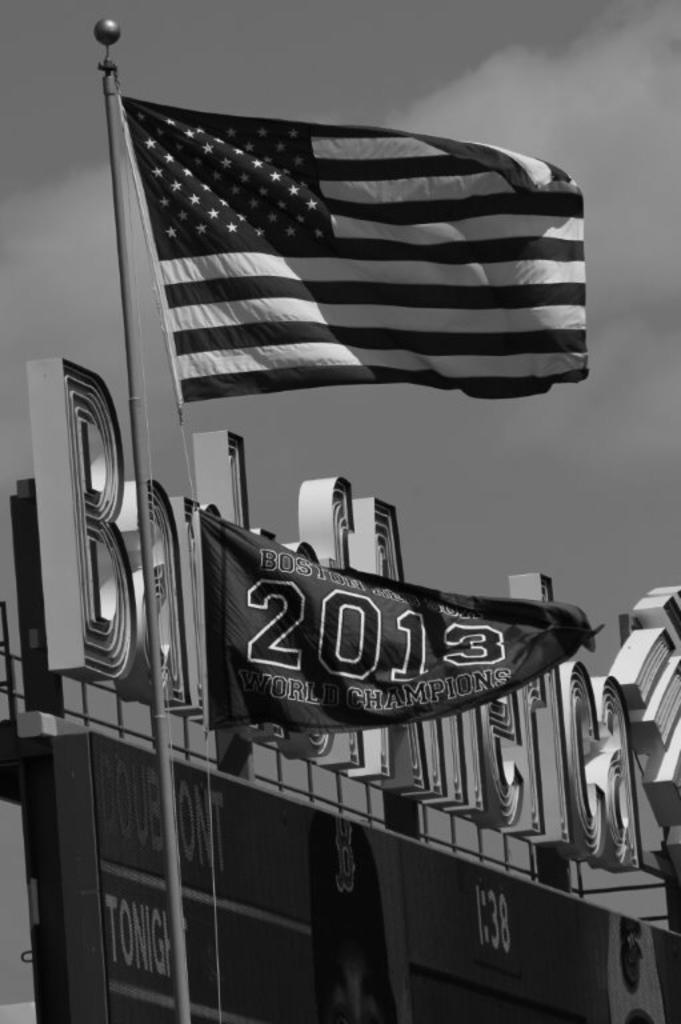<image>
Present a compact description of the photo's key features. some flags reading 2013 World Champions in front of a stadium 